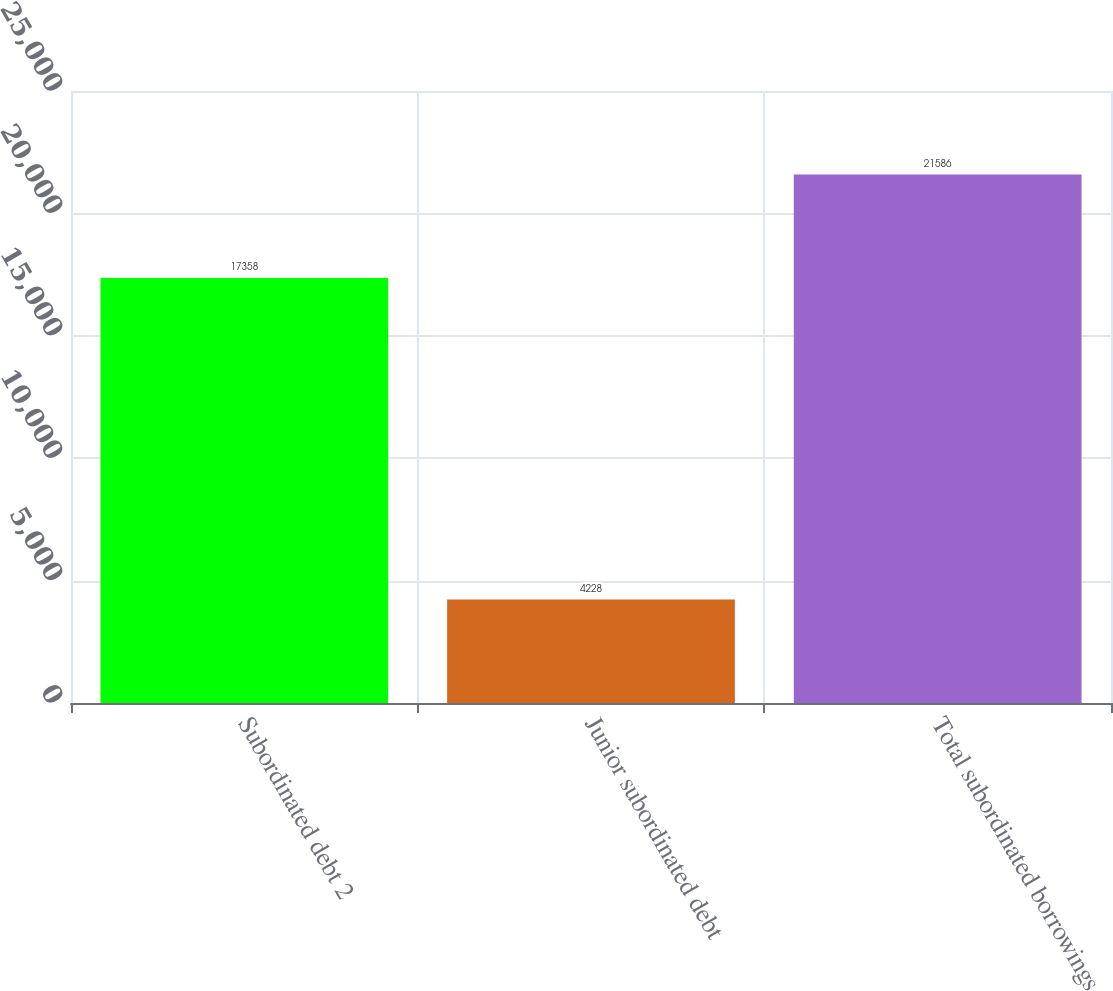<chart> <loc_0><loc_0><loc_500><loc_500><bar_chart><fcel>Subordinated debt 2<fcel>Junior subordinated debt<fcel>Total subordinated borrowings<nl><fcel>17358<fcel>4228<fcel>21586<nl></chart> 